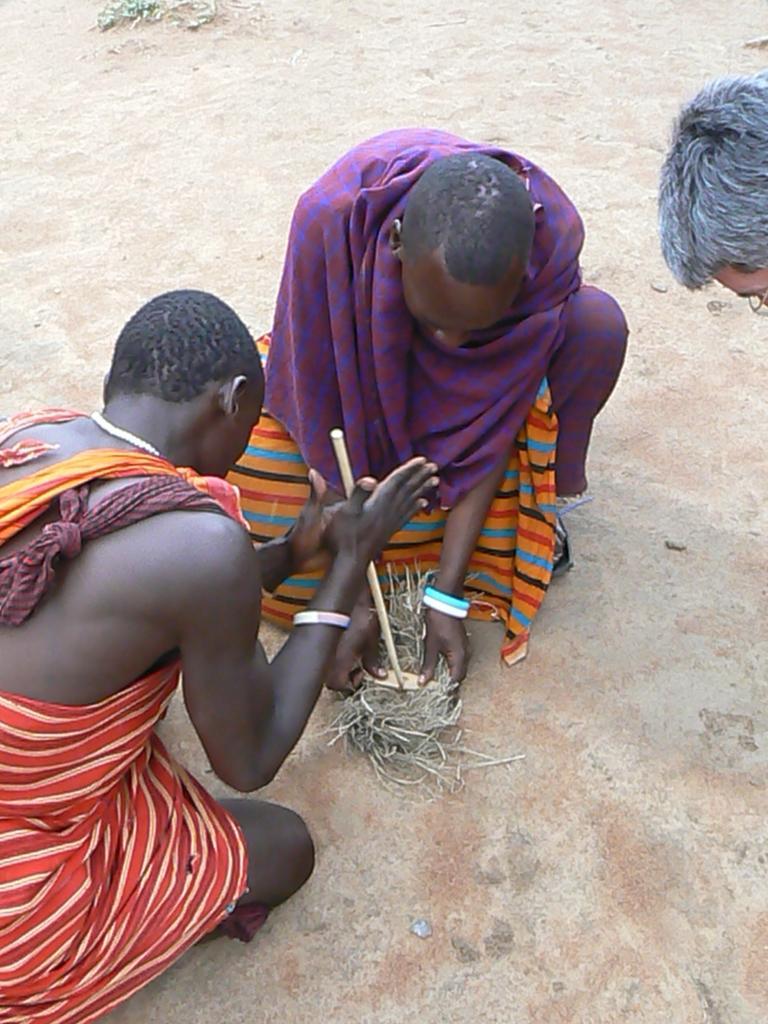Can you describe this image briefly? In this image there are two people laying on their knees on a ground, holding few objects in their hands, beside them there is a person bending. 